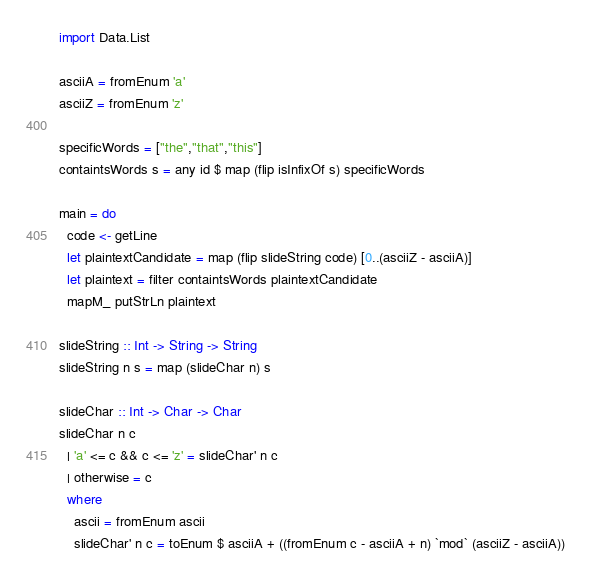<code> <loc_0><loc_0><loc_500><loc_500><_Haskell_>
import Data.List

asciiA = fromEnum 'a'
asciiZ = fromEnum 'z'

specificWords = ["the","that","this"]
containtsWords s = any id $ map (flip isInfixOf s) specificWords

main = do
  code <- getLine
  let plaintextCandidate = map (flip slideString code) [0..(asciiZ - asciiA)]
  let plaintext = filter containtsWords plaintextCandidate
  mapM_ putStrLn plaintext

slideString :: Int -> String -> String
slideString n s = map (slideChar n) s

slideChar :: Int -> Char -> Char
slideChar n c 
  | 'a' <= c && c <= 'z' = slideChar' n c
  | otherwise = c
  where 
    ascii = fromEnum ascii
    slideChar' n c = toEnum $ asciiA + ((fromEnum c - asciiA + n) `mod` (asciiZ - asciiA))



</code> 